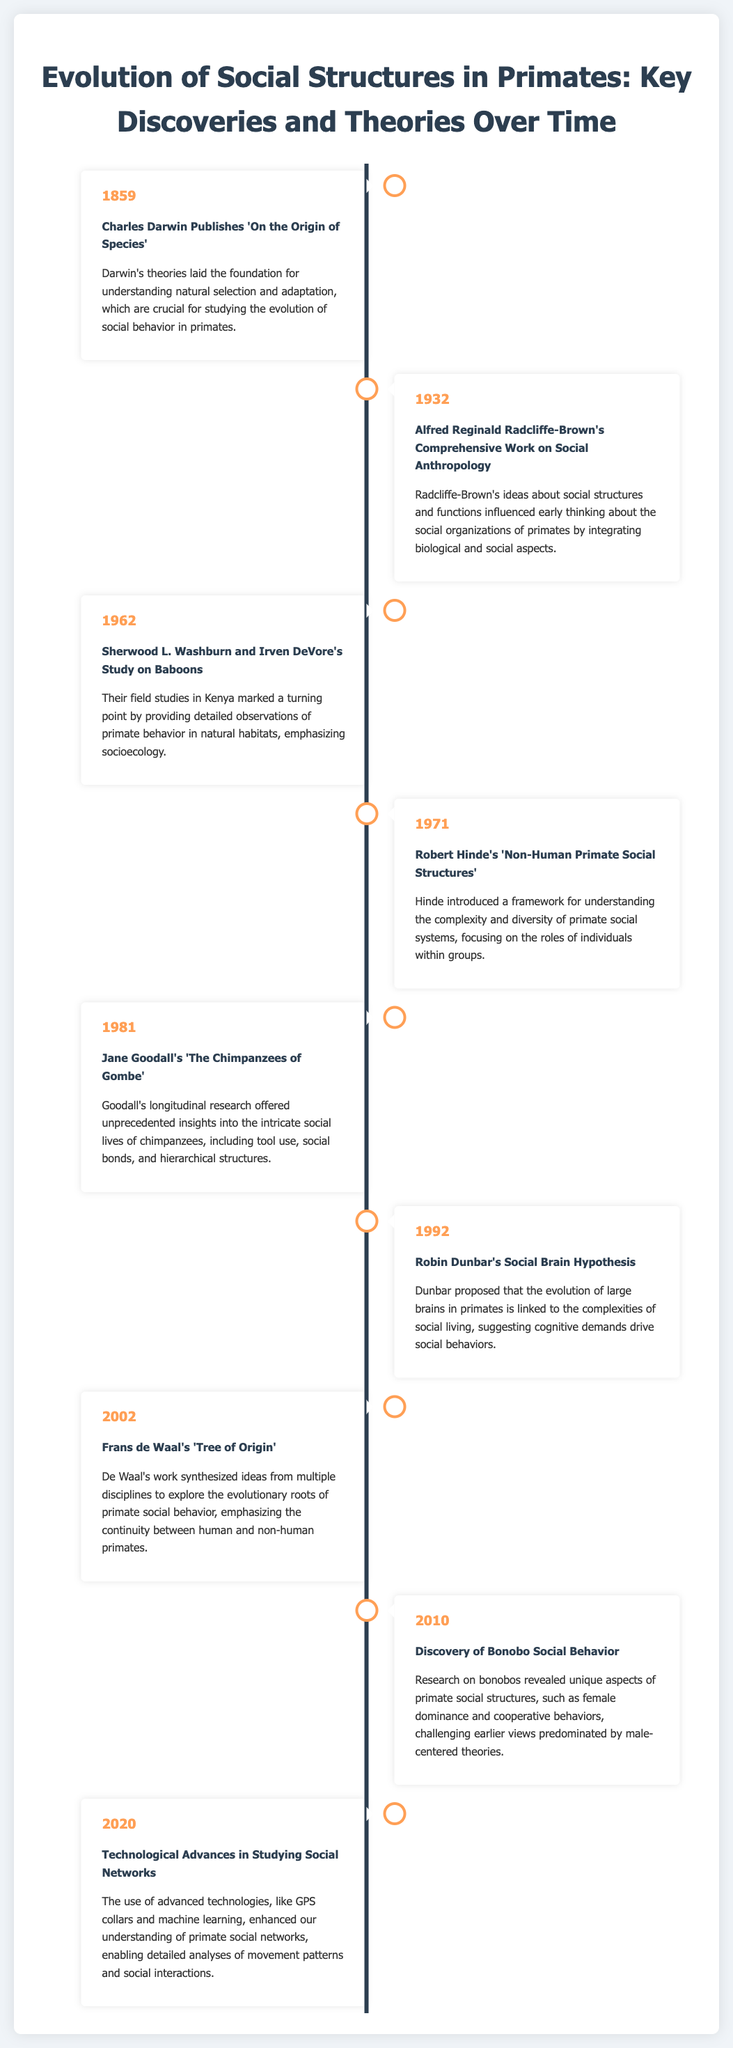What year did Charles Darwin publish 'On the Origin of Species'? The document states that Darwin published his landmark work in 1859.
Answer: 1859 Who conducted the study on baboons in 1962? According to the timeline, the study on baboons was conducted by Sherwood L. Washburn and Irven DeVore.
Answer: Sherwood L. Washburn and Irven DeVore What hypothesis did Robin Dunbar propose in 1992? The document notes that Robin Dunbar proposed the Social Brain Hypothesis in 1992.
Answer: Social Brain Hypothesis What unique aspect of bonobo social behavior was discovered in 2010? The document mentions that research revealed female dominance in bonobo social structures.
Answer: Female dominance Which year marked the publication of Jane Goodall's research on chimpanzees? The timeline indicates that Jane Goodall's work was published in 1981.
Answer: 1981 How did technological advances in 2020 impact the study of primate social networks? The document explains that technological advances enhanced understanding and analysis of primate social networks.
Answer: Enhanced understanding What was a significant discovery made by Frans de Waal in 2002? According to the infographic, De Waal's work explored the evolutionary roots of primate social behavior.
Answer: Evolutionary roots of primate social behavior Which two researchers focused on social structures in primates before the year 2000? The document lists Robert Hinde and Jane Goodall as researchers on the topic before 2000.
Answer: Robert Hinde and Jane Goodall What is the overall theme of the timeline document? The timeline outlines key discoveries and theories related to the evolution of social structures in primates over time.
Answer: Evolution of social structures in primates 